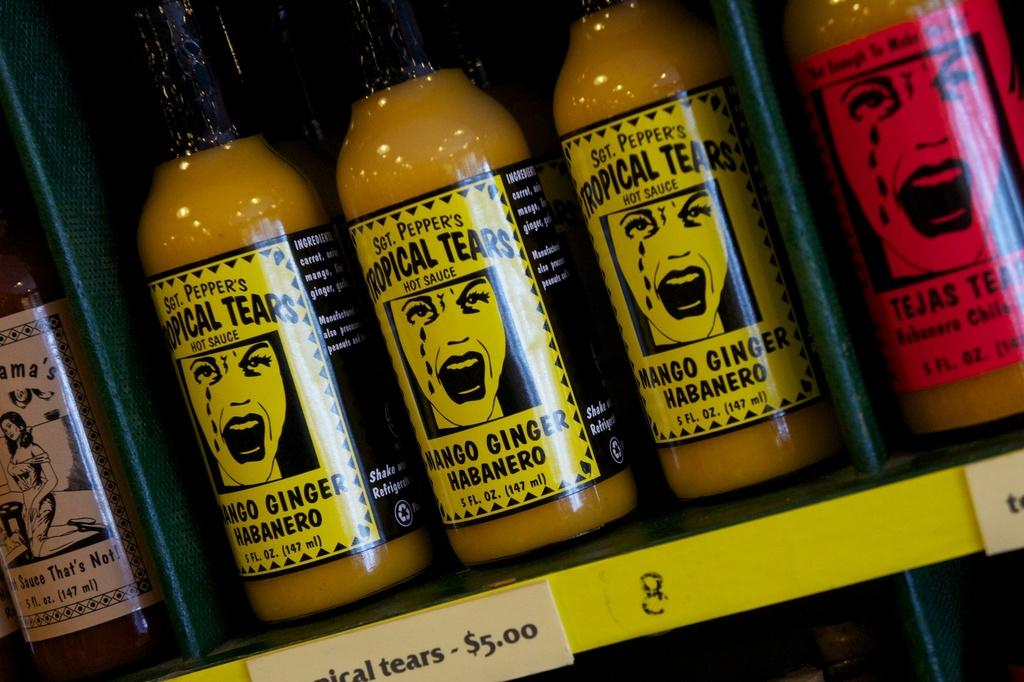Provide a one-sentence caption for the provided image. three bottles of tropical tears hot sauce being sold for $5.00. 